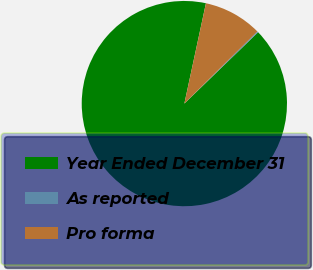Convert chart to OTSL. <chart><loc_0><loc_0><loc_500><loc_500><pie_chart><fcel>Year Ended December 31<fcel>As reported<fcel>Pro forma<nl><fcel>90.61%<fcel>0.17%<fcel>9.22%<nl></chart> 